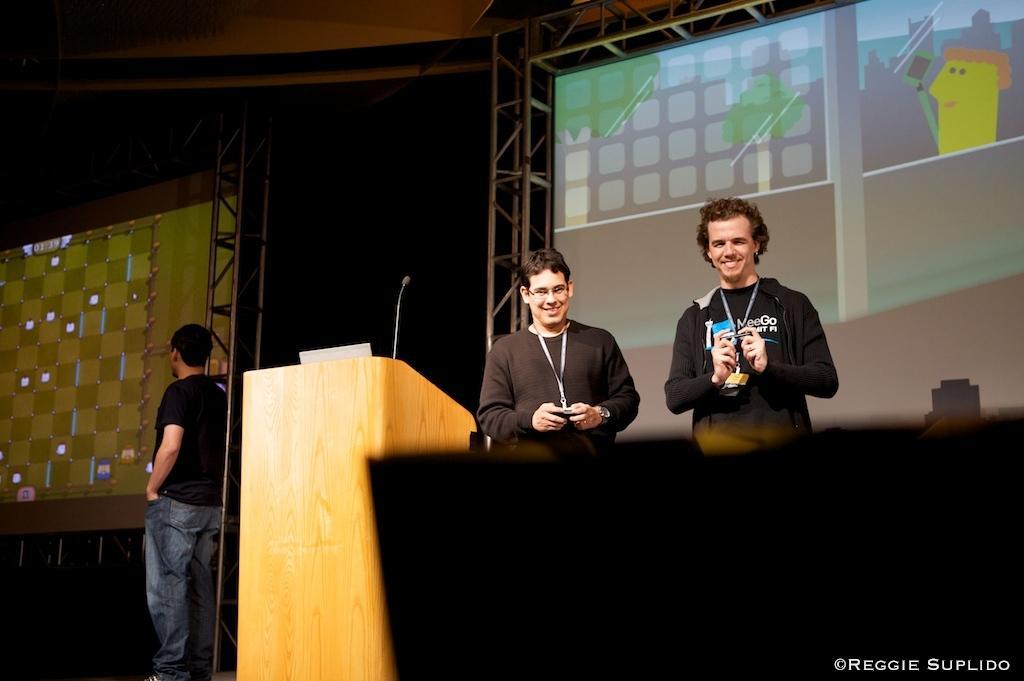How would you summarize this image in a sentence or two? There are two persons wearing black dress is standing and holding an object in their hands and there is a wooden stand beside them and there is another person standing in the left corner. 